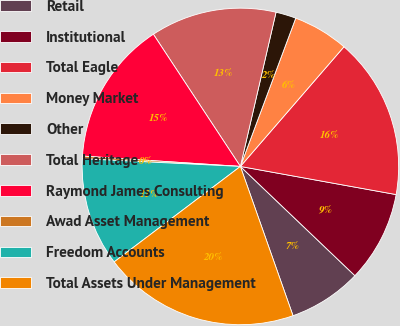Convert chart to OTSL. <chart><loc_0><loc_0><loc_500><loc_500><pie_chart><fcel>Retail<fcel>Institutional<fcel>Total Eagle<fcel>Money Market<fcel>Other<fcel>Total Heritage<fcel>Raymond James Consulting<fcel>Awad Asset Management<fcel>Freedom Accounts<fcel>Total Assets Under Management<nl><fcel>7.48%<fcel>9.28%<fcel>16.49%<fcel>5.67%<fcel>2.07%<fcel>12.88%<fcel>14.69%<fcel>0.27%<fcel>11.08%<fcel>20.09%<nl></chart> 